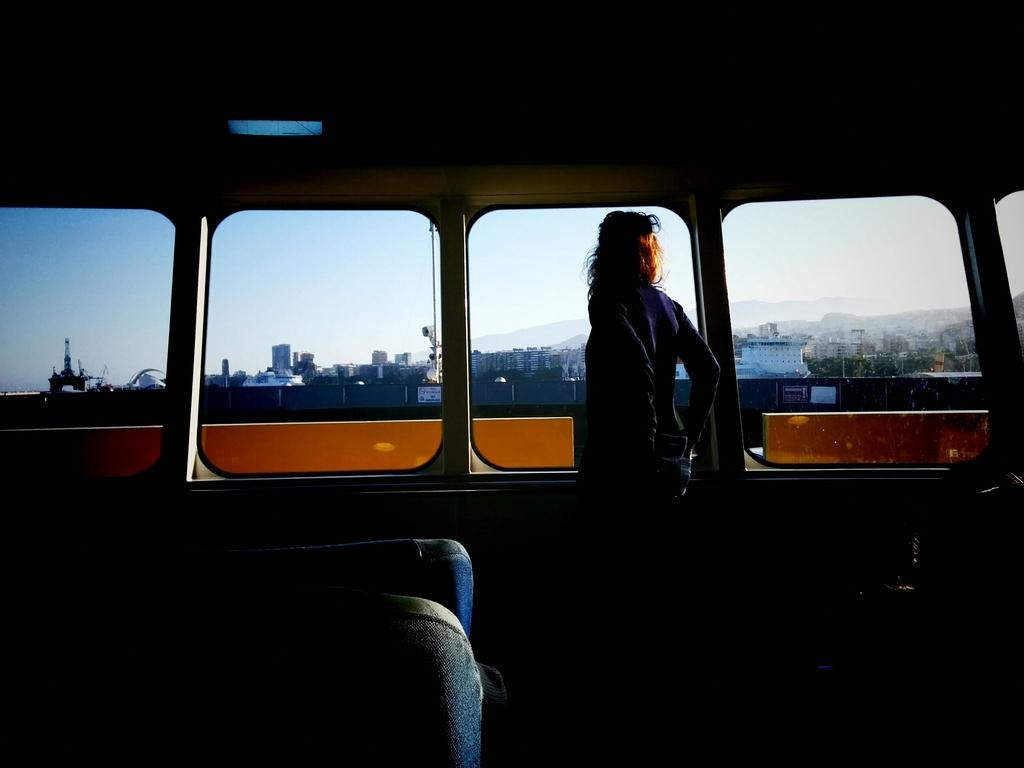What is the person in the image doing? The person is standing in a vehicle. What type of windows does the vehicle have? The vehicle has glass windows. What can be seen through the glass windows? Buildings, clouds, and the sky are visible through the glass windows. How many corn cobs are visible in the image? There are no corn cobs present in the image. What type of glove is the person wearing in the image? There is no glove visible in the image. 